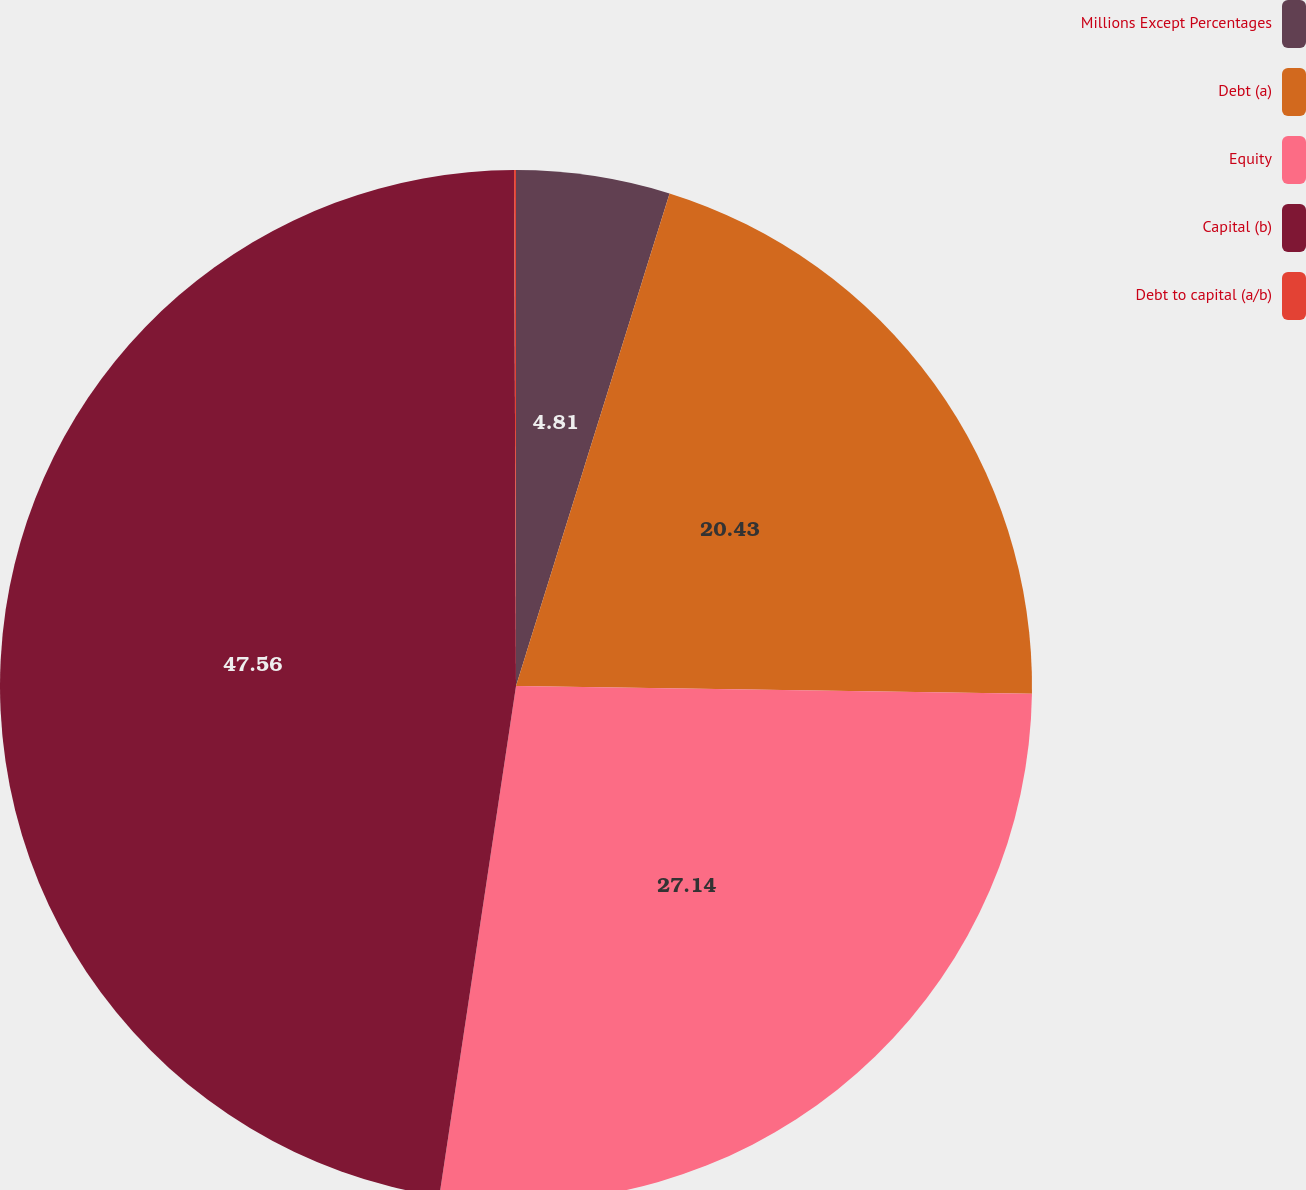Convert chart to OTSL. <chart><loc_0><loc_0><loc_500><loc_500><pie_chart><fcel>Millions Except Percentages<fcel>Debt (a)<fcel>Equity<fcel>Capital (b)<fcel>Debt to capital (a/b)<nl><fcel>4.81%<fcel>20.43%<fcel>27.14%<fcel>47.57%<fcel>0.06%<nl></chart> 